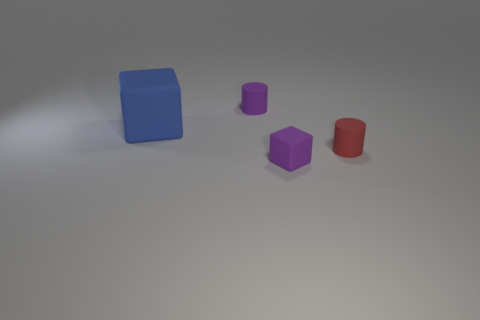Add 3 large yellow shiny cylinders. How many objects exist? 7 Subtract all cyan metallic spheres. Subtract all big things. How many objects are left? 3 Add 1 blue cubes. How many blue cubes are left? 2 Add 1 brown matte balls. How many brown matte balls exist? 1 Subtract 1 blue blocks. How many objects are left? 3 